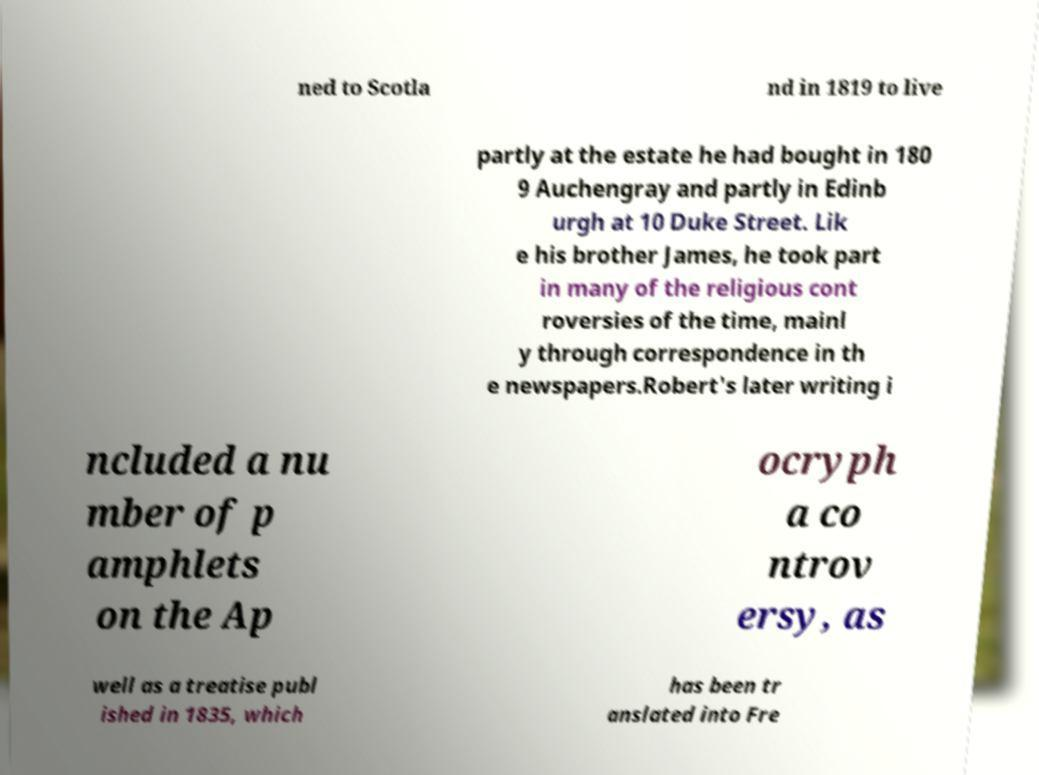Could you assist in decoding the text presented in this image and type it out clearly? ned to Scotla nd in 1819 to live partly at the estate he had bought in 180 9 Auchengray and partly in Edinb urgh at 10 Duke Street. Lik e his brother James, he took part in many of the religious cont roversies of the time, mainl y through correspondence in th e newspapers.Robert's later writing i ncluded a nu mber of p amphlets on the Ap ocryph a co ntrov ersy, as well as a treatise publ ished in 1835, which has been tr anslated into Fre 